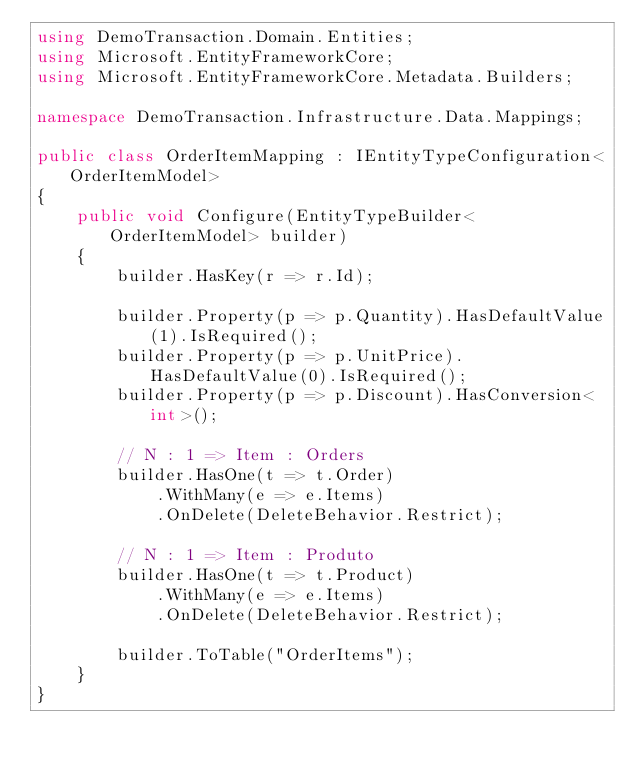Convert code to text. <code><loc_0><loc_0><loc_500><loc_500><_C#_>using DemoTransaction.Domain.Entities;
using Microsoft.EntityFrameworkCore;
using Microsoft.EntityFrameworkCore.Metadata.Builders;

namespace DemoTransaction.Infrastructure.Data.Mappings;

public class OrderItemMapping : IEntityTypeConfiguration<OrderItemModel>
{
    public void Configure(EntityTypeBuilder<OrderItemModel> builder)
    {
        builder.HasKey(r => r.Id);

        builder.Property(p => p.Quantity).HasDefaultValue(1).IsRequired();
        builder.Property(p => p.UnitPrice).HasDefaultValue(0).IsRequired();
        builder.Property(p => p.Discount).HasConversion<int>();

        // N : 1 => Item : Orders
        builder.HasOne(t => t.Order)
            .WithMany(e => e.Items)
            .OnDelete(DeleteBehavior.Restrict);

        // N : 1 => Item : Produto
        builder.HasOne(t => t.Product)
            .WithMany(e => e.Items)
            .OnDelete(DeleteBehavior.Restrict);

        builder.ToTable("OrderItems");
    }
}
</code> 